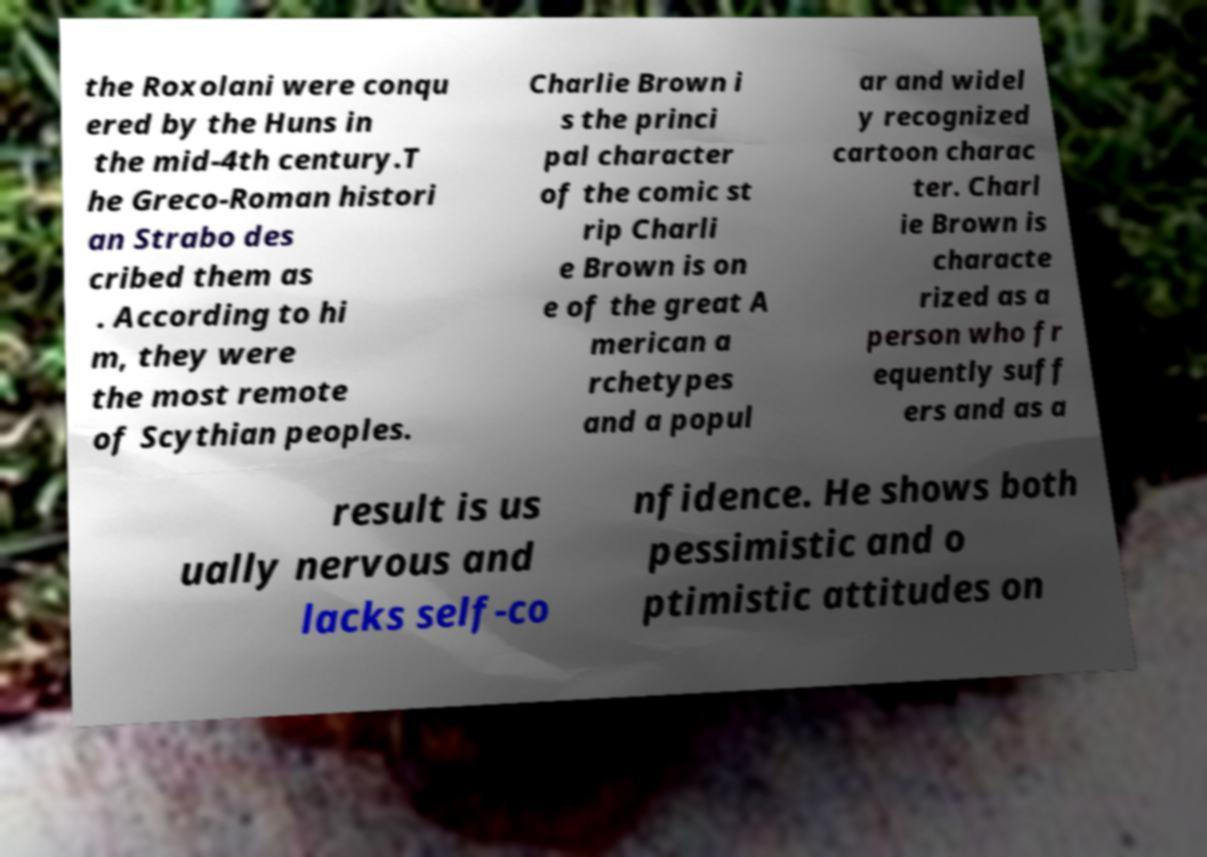Can you read and provide the text displayed in the image?This photo seems to have some interesting text. Can you extract and type it out for me? the Roxolani were conqu ered by the Huns in the mid-4th century.T he Greco-Roman histori an Strabo des cribed them as . According to hi m, they were the most remote of Scythian peoples. Charlie Brown i s the princi pal character of the comic st rip Charli e Brown is on e of the great A merican a rchetypes and a popul ar and widel y recognized cartoon charac ter. Charl ie Brown is characte rized as a person who fr equently suff ers and as a result is us ually nervous and lacks self-co nfidence. He shows both pessimistic and o ptimistic attitudes on 